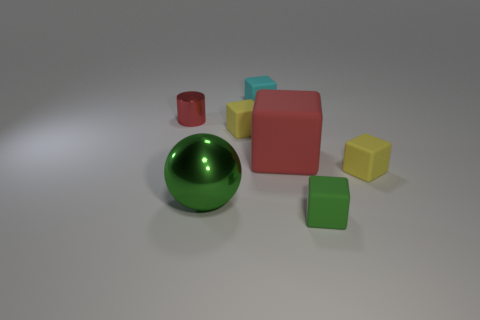What color is the small cylinder?
Provide a succinct answer. Red. Do the big cube and the small shiny cylinder have the same color?
Provide a short and direct response. Yes. How many green matte cubes are left of the big sphere that is to the left of the large red cube?
Give a very brief answer. 0. There is a cube that is both in front of the cyan rubber object and left of the red matte thing; what is its size?
Offer a terse response. Small. What is the tiny cube that is behind the red shiny thing made of?
Give a very brief answer. Rubber. Is there a red rubber thing that has the same shape as the tiny red metallic object?
Provide a short and direct response. No. How many small yellow things have the same shape as the small green thing?
Offer a very short reply. 2. Is the size of the cube that is in front of the large green ball the same as the yellow rubber block that is to the right of the small green matte thing?
Your answer should be compact. Yes. There is a tiny object left of the yellow matte cube left of the cyan matte thing; what is its shape?
Ensure brevity in your answer.  Cylinder. Are there the same number of large shiny things that are in front of the large metal thing and tiny yellow things?
Provide a succinct answer. No. 